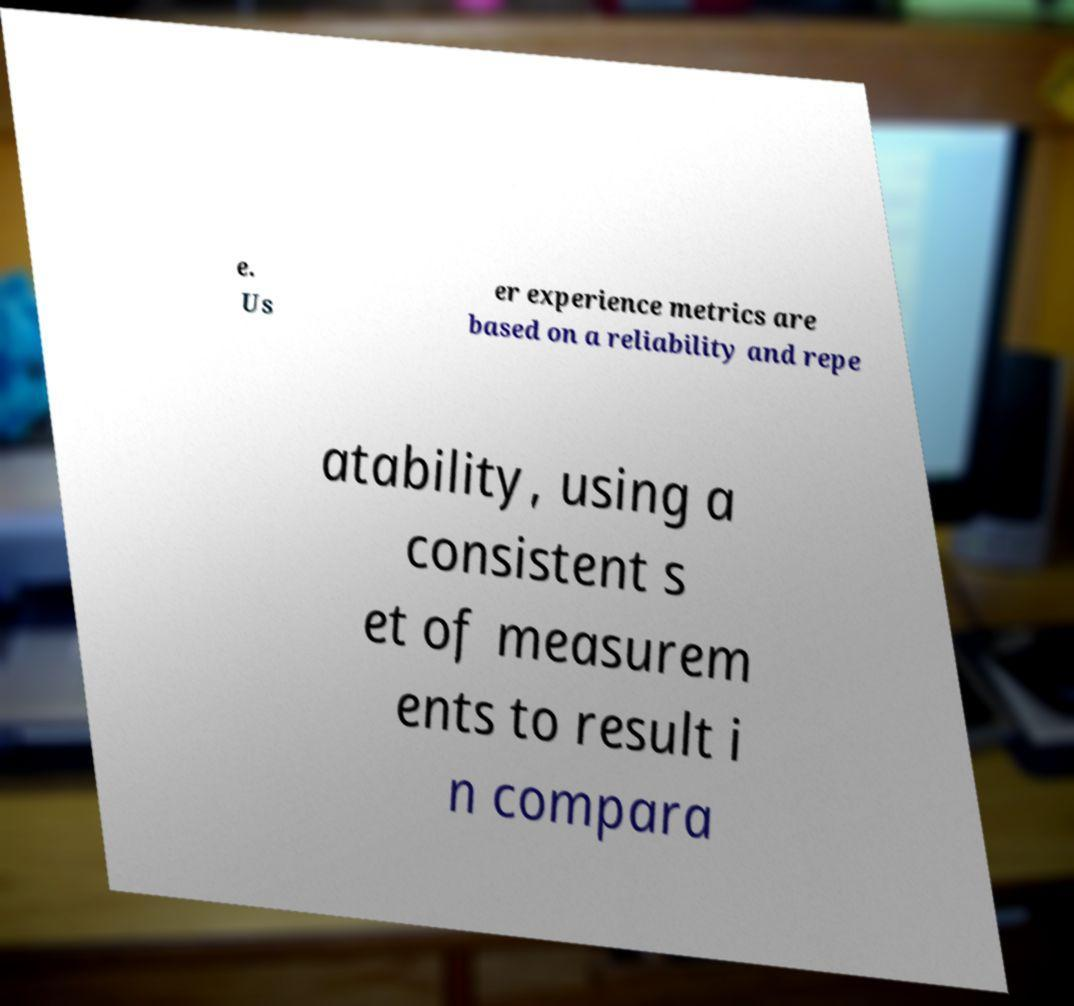Could you assist in decoding the text presented in this image and type it out clearly? e. Us er experience metrics are based on a reliability and repe atability, using a consistent s et of measurem ents to result i n compara 